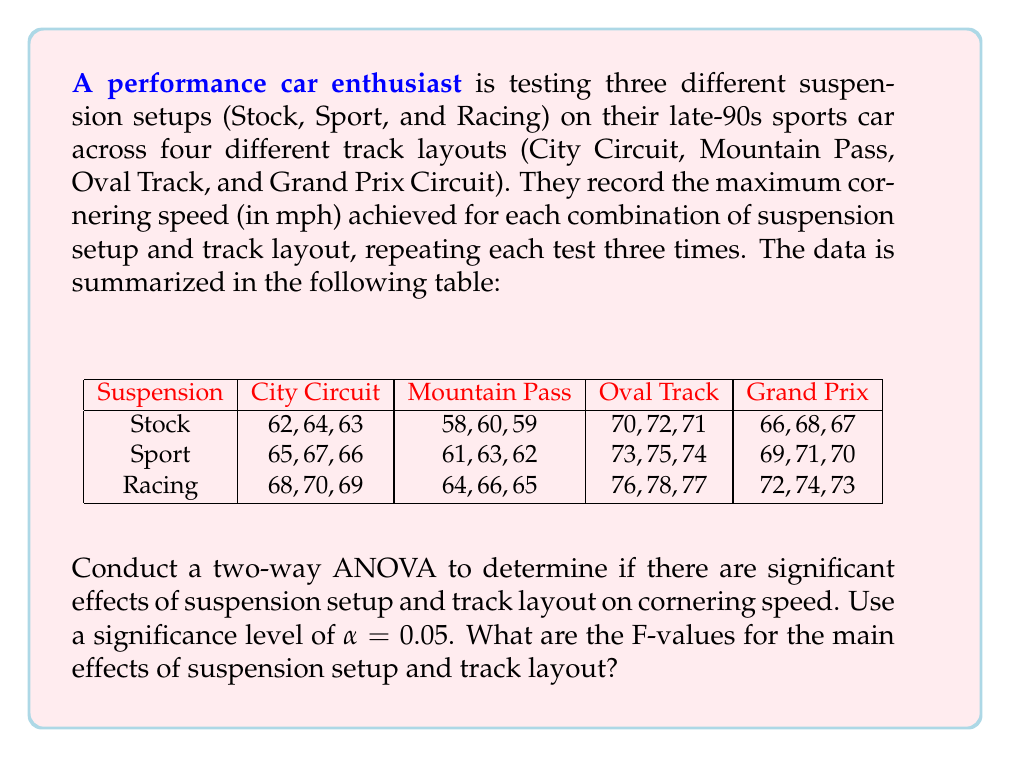Give your solution to this math problem. To conduct a two-way ANOVA, we need to calculate the following:

1. Sum of Squares for Suspension (SS_A)
2. Sum of Squares for Track Layout (SS_B)
3. Sum of Squares for Interaction (SS_AB)
4. Sum of Squares for Error (SS_E)
5. Sum of Squares Total (SS_T)

Step 1: Calculate the grand mean and total sum of squares
Grand mean: $\bar{X} = 68.0$
SS_T = 2106

Step 2: Calculate SS_A (Suspension)
$$SS_A = 3 \cdot 4 \cdot \sum_{i=1}^{3} (\bar{X_i} - \bar{X})^2 = 450$$

Step 3: Calculate SS_B (Track Layout)
$$SS_B = 3 \cdot 3 \cdot \sum_{j=1}^{4} (\bar{X_j} - \bar{X})^2 = 1620$$

Step 4: Calculate SS_AB (Interaction)
$$SS_{AB} = 3 \cdot \sum_{i=1}^{3} \sum_{j=1}^{4} (\bar{X_{ij}} - \bar{X_i} - \bar{X_j} + \bar{X})^2 = 0$$

Step 5: Calculate SS_E (Error)
$$SS_E = SS_T - SS_A - SS_B - SS_{AB} = 36$$

Step 6: Calculate degrees of freedom
df_A = 2, df_B = 3, df_AB = 6, df_E = 24

Step 7: Calculate Mean Squares
MS_A = SS_A / df_A = 225
MS_B = SS_B / df_B = 540
MS_AB = SS_AB / df_AB = 0
MS_E = SS_E / df_E = 1.5

Step 8: Calculate F-values
F_A = MS_A / MS_E = 150
F_B = MS_B / MS_E = 360

Step 9: Compare F-values to critical F-values
F_critical(2, 24, 0.05) ≈ 3.40
F_critical(3, 24, 0.05) ≈ 3.01

Both F_A and F_B are greater than their respective critical F-values, indicating significant main effects for both suspension setup and track layout.
Answer: The F-values for the main effects are:
Suspension setup: F_A = 150
Track layout: F_B = 360 